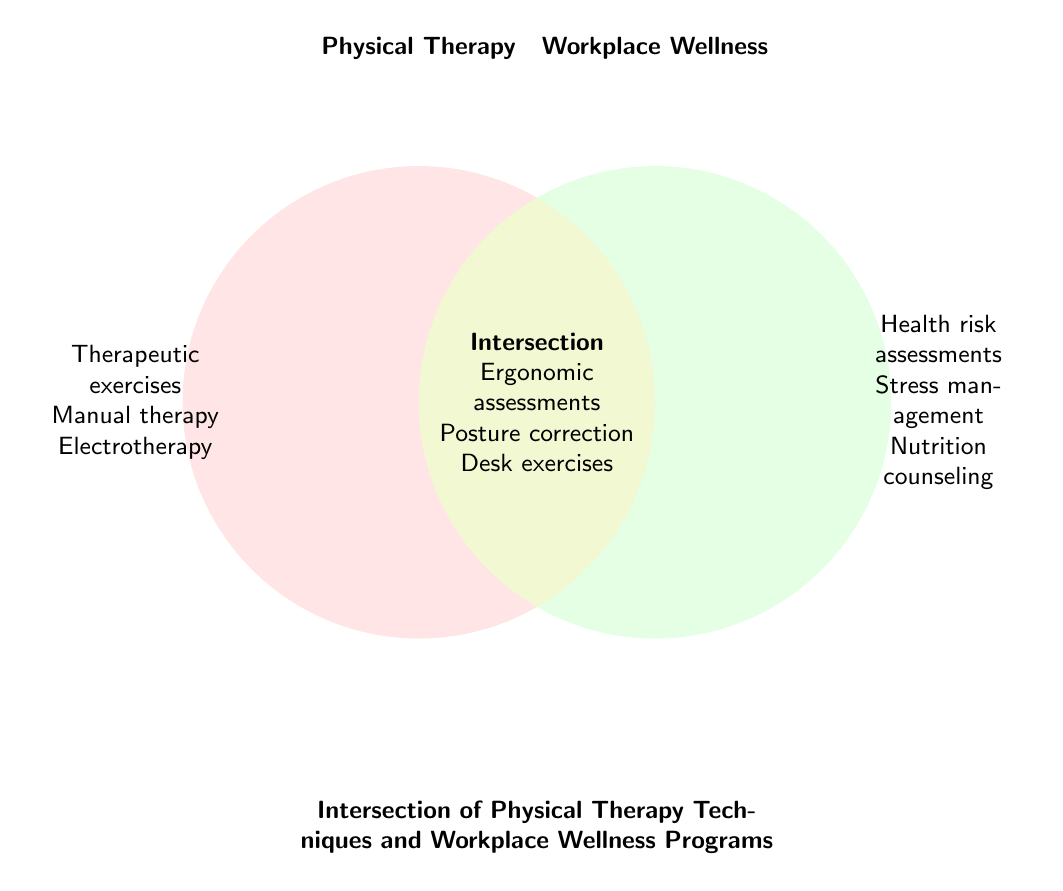What's the title of the figure? The title of the figure is usually located at the top or the bottom, providing a description of what the figure represents. In this case, it's "Intersection of Physical Therapy Techniques and Workplace Wellness Programs".
Answer: Intersection of Physical Therapy Techniques and Workplace Wellness Programs How many elements are listed exclusively under Physical Therapy? To find this, look at the left circle labeled Physical Therapy and count the distinct elements listed there: Therapeutic exercises, Manual therapy, Electrotherapy.
Answer: 3 Which elements are found in both Physical Therapy and Workplace Wellness? Check the intersection part of the Venn Diagram where elements common to both categories are listed: Ergonomic assessments, Posture correction training, Desk exercise routines.
Answer: Ergonomic assessments, Posture correction training, Desk exercise routines Compare the number of elements exclusive to Physical Therapy and Workplace Wellness. Which one has more? Count the elements exclusive to each category: Physical Therapy has 3 elements, Workplace Wellness has 3 elements. Since both have 3 elements, neither has more.
Answer: Both have the same number What elements are listed exclusively in Workplace Wellness Programs? Look at the right circle labeled Workplace Wellness and count the distinct elements listed there: Health risk assessments, Stress management workshops, Nutrition counseling.
Answer: Health risk assessments, Stress management workshops, Nutrition counseling Which specific element in the intersection category helps with back pain? In the intersection part of the Venn Diagram, identify the element focused on back health: Back pain prevention classes.
Answer: Back pain prevention classes If a company wants to implement programs from both Physical Therapy and Workplace Wellness, how many unique techniques or activities can they choose from the Intersection area? The number of unique techniques in the Intersection can be counted directly from the intersection area of the Venn Diagram: There are 3 unique activities.
Answer: 3 How do the number of elements in Physical Therapy and the Intersection compare? Compare the number of elements exclusively in Physical Therapy (3) with those in the Intersection (3). Since both have the same number, they are equal.
Answer: They are equal List a technique or activity from the Intersection that involves exercise. Look at the types of activities in the Intersection and identify ones that involve exercise: Desk exercise routines.
Answer: Desk exercise routines What's the total number of unique elements across all three sections? Sum up all unique elements from Physical Therapy (3), Workplace Wellness (3), and Intersection (3): Total unique elements are 3 + 3 + 3 = 9.
Answer: 9 